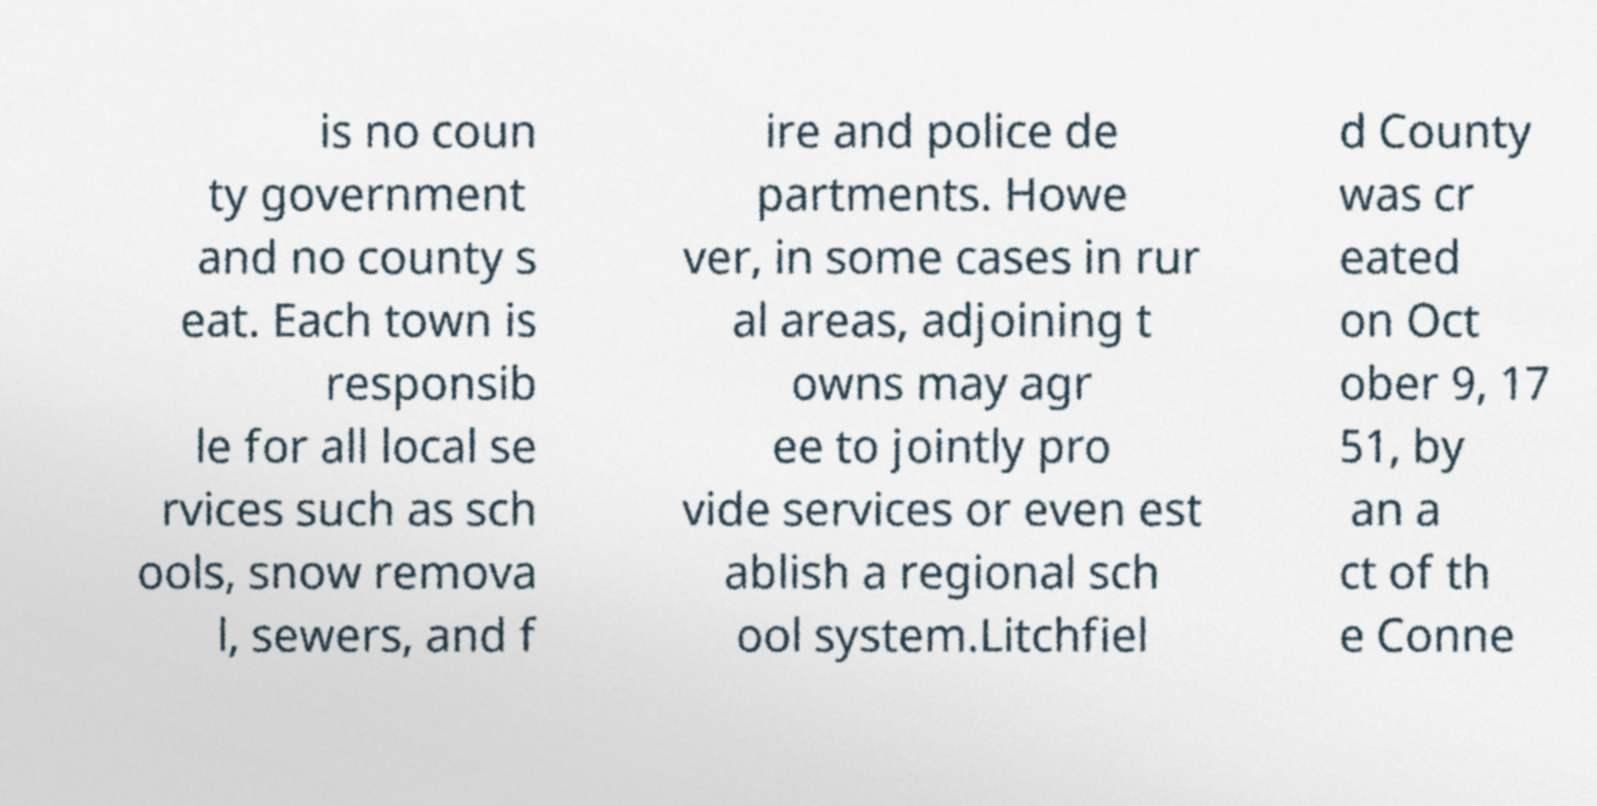Could you assist in decoding the text presented in this image and type it out clearly? is no coun ty government and no county s eat. Each town is responsib le for all local se rvices such as sch ools, snow remova l, sewers, and f ire and police de partments. Howe ver, in some cases in rur al areas, adjoining t owns may agr ee to jointly pro vide services or even est ablish a regional sch ool system.Litchfiel d County was cr eated on Oct ober 9, 17 51, by an a ct of th e Conne 